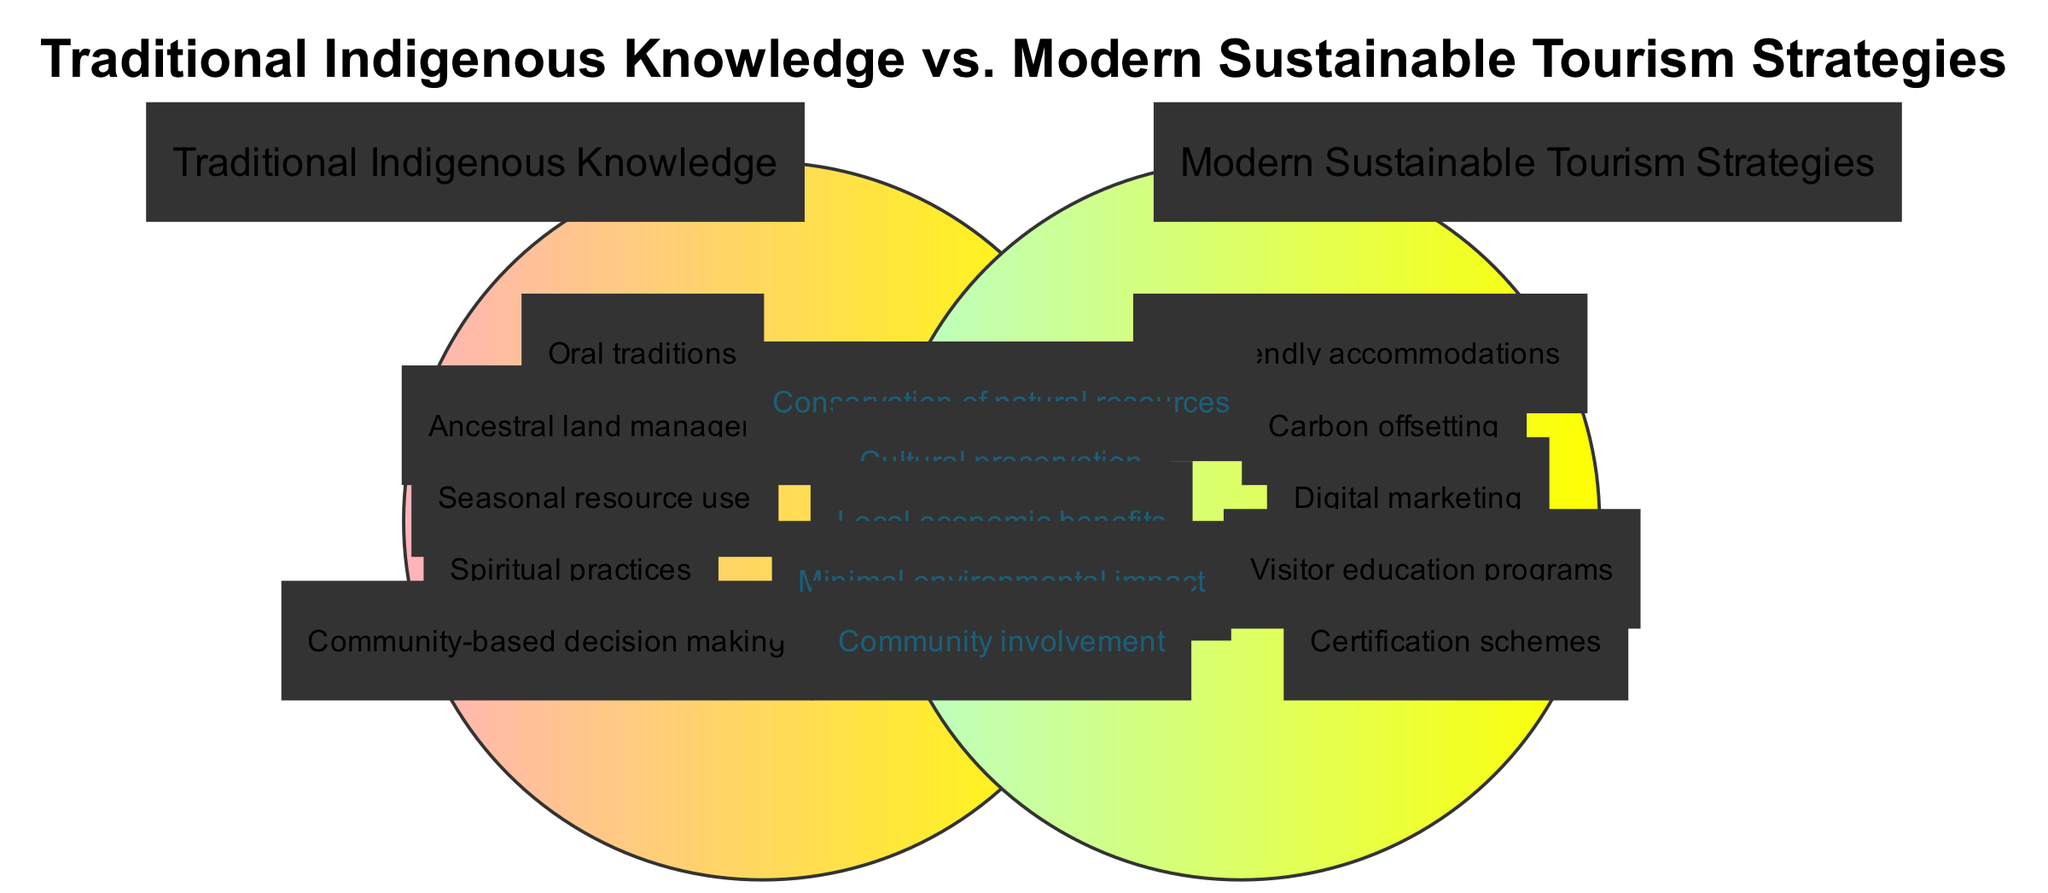What are two elements of Traditional Indigenous Knowledge? According to the diagram, the elements listed under Traditional Indigenous Knowledge include oral traditions, ancestral land management, seasonal resource use, spiritual practices, and community-based decision making. Therefore, two elements can be any two from this list, such as 'oral traditions' and 'seasonal resource use'.
Answer: oral traditions, seasonal resource use How many elements are there in Modern Sustainable Tourism Strategies? The diagram specifies five elements under the section for Modern Sustainable Tourism Strategies: eco-friendly accommodations, carbon offsetting, digital marketing, visitor education programs, and certification schemes. Counting these gives a total of five elements.
Answer: 5 What is one key concept found in the intersection of both circles? The intersection of the circles illustrates shared concepts that relate to both Traditional Indigenous Knowledge and Modern Sustainable Tourism Strategies. One of these concepts is cultural preservation, which exemplifies the shared aim of maintaining cultural traditions while promoting sustainable tourism.
Answer: cultural preservation Name an element that is solely found in Traditional Indigenous Knowledge. The diagram indicates that oral traditions, ancestral land management, seasonal resource use, spiritual practices, and community-based decision making are unique elements of Traditional Indigenous Knowledge. Selecting any one of these, such as 'spiritual practices', satisfies this query.
Answer: spiritual practices What do both Traditional Indigenous Knowledge and Modern Sustainable Tourism Strategies have in common regarding environmental impact? Upon analyzing the intersection of the diagram, one commonality is minimal environmental impact, which reflects how both approaches prioritize sustainability in their practices and principles.
Answer: minimal environmental impact 